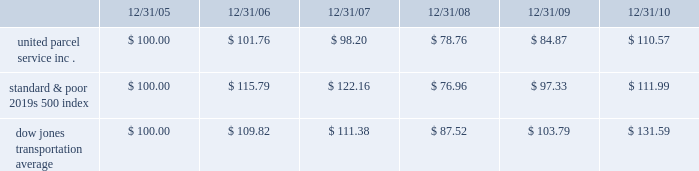Shareowner return performance graph the following performance graph and related information shall not be deemed 201csoliciting material 201d or to be 201cfiled 201d with the securities and exchange commission , nor shall such information be incorporated by reference into any future filing under the securities act of 1933 or securities exchange act of 1934 , each as amended , except to the extent that the company specifically incorporates such information by reference into such filing .
The following graph shows a five year comparison of cumulative total shareowners 2019 returns for our class b common stock , the standard & poor 2019s 500 index , and the dow jones transportation average .
The comparison of the total cumulative return on investment , which is the change in the quarterly stock price plus reinvested dividends for each of the quarterly periods , assumes that $ 100 was invested on december 31 , 2005 in the standard & poor 2019s 500 index , the dow jones transportation average , and our class b common stock .
Comparison of five year cumulative total return $ 40.00 $ 60.00 $ 80.00 $ 100.00 $ 120.00 $ 140.00 $ 160.00 201020092008200720062005 s&p 500 ups dj transport .

What is the difference in total cumulative return on investment between united parcel service inc . and the dow jones transportation average for the five year period ending 12/31/10? 
Computations: ((131.59 - 100) / 100)
Answer: 0.3159. 